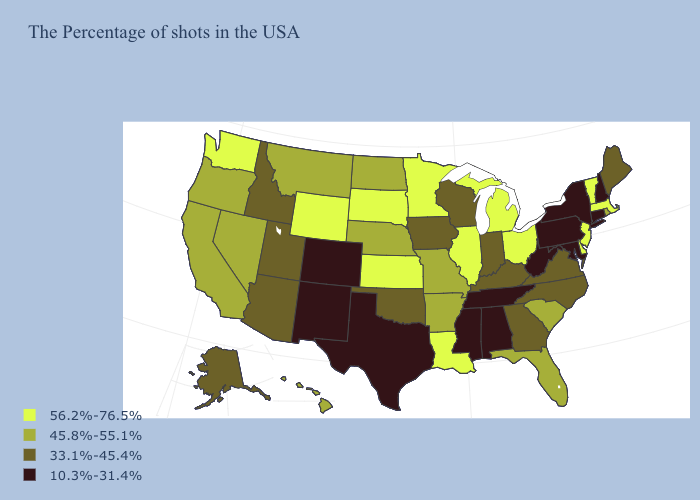Among the states that border Virginia , does North Carolina have the highest value?
Short answer required. Yes. Which states have the lowest value in the South?
Give a very brief answer. Maryland, West Virginia, Alabama, Tennessee, Mississippi, Texas. Name the states that have a value in the range 56.2%-76.5%?
Give a very brief answer. Massachusetts, Vermont, New Jersey, Delaware, Ohio, Michigan, Illinois, Louisiana, Minnesota, Kansas, South Dakota, Wyoming, Washington. Does the map have missing data?
Keep it brief. No. What is the value of Connecticut?
Write a very short answer. 10.3%-31.4%. What is the value of South Carolina?
Give a very brief answer. 45.8%-55.1%. Which states have the lowest value in the USA?
Write a very short answer. New Hampshire, Connecticut, New York, Maryland, Pennsylvania, West Virginia, Alabama, Tennessee, Mississippi, Texas, Colorado, New Mexico. Does Pennsylvania have a lower value than Colorado?
Quick response, please. No. What is the lowest value in the West?
Quick response, please. 10.3%-31.4%. How many symbols are there in the legend?
Write a very short answer. 4. What is the value of West Virginia?
Give a very brief answer. 10.3%-31.4%. Does Washington have the lowest value in the West?
Keep it brief. No. How many symbols are there in the legend?
Short answer required. 4. What is the highest value in the USA?
Keep it brief. 56.2%-76.5%. What is the value of Mississippi?
Answer briefly. 10.3%-31.4%. 